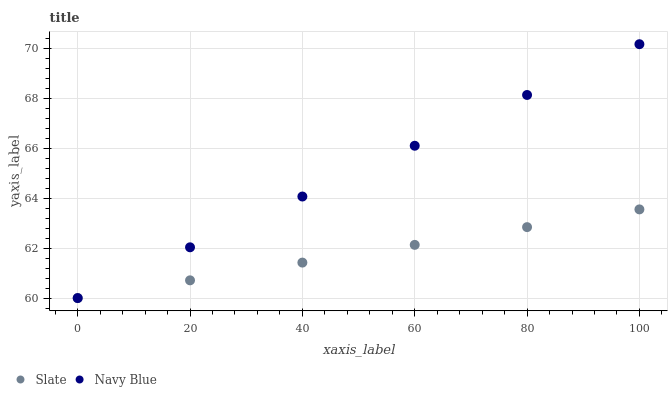Does Slate have the minimum area under the curve?
Answer yes or no. Yes. Does Navy Blue have the maximum area under the curve?
Answer yes or no. Yes. Does Slate have the maximum area under the curve?
Answer yes or no. No. Is Navy Blue the smoothest?
Answer yes or no. Yes. Is Slate the roughest?
Answer yes or no. Yes. Does Navy Blue have the lowest value?
Answer yes or no. Yes. Does Navy Blue have the highest value?
Answer yes or no. Yes. Does Slate have the highest value?
Answer yes or no. No. Does Slate intersect Navy Blue?
Answer yes or no. Yes. Is Slate less than Navy Blue?
Answer yes or no. No. Is Slate greater than Navy Blue?
Answer yes or no. No. 